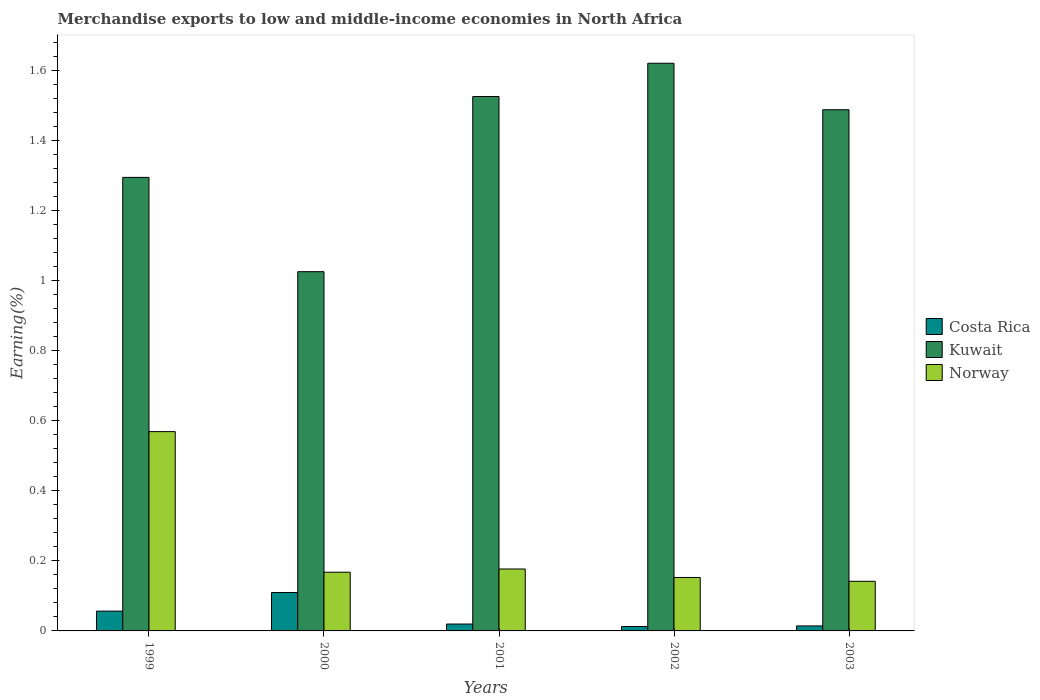How many different coloured bars are there?
Your response must be concise. 3. Are the number of bars on each tick of the X-axis equal?
Your response must be concise. Yes. How many bars are there on the 2nd tick from the right?
Your answer should be very brief. 3. What is the label of the 2nd group of bars from the left?
Keep it short and to the point. 2000. What is the percentage of amount earned from merchandise exports in Costa Rica in 1999?
Your answer should be very brief. 0.06. Across all years, what is the maximum percentage of amount earned from merchandise exports in Kuwait?
Your answer should be very brief. 1.62. Across all years, what is the minimum percentage of amount earned from merchandise exports in Norway?
Make the answer very short. 0.14. In which year was the percentage of amount earned from merchandise exports in Norway maximum?
Provide a succinct answer. 1999. What is the total percentage of amount earned from merchandise exports in Kuwait in the graph?
Keep it short and to the point. 6.95. What is the difference between the percentage of amount earned from merchandise exports in Costa Rica in 1999 and that in 2002?
Your answer should be very brief. 0.04. What is the difference between the percentage of amount earned from merchandise exports in Kuwait in 2003 and the percentage of amount earned from merchandise exports in Costa Rica in 1999?
Give a very brief answer. 1.43. What is the average percentage of amount earned from merchandise exports in Costa Rica per year?
Make the answer very short. 0.04. In the year 2000, what is the difference between the percentage of amount earned from merchandise exports in Norway and percentage of amount earned from merchandise exports in Kuwait?
Make the answer very short. -0.86. What is the ratio of the percentage of amount earned from merchandise exports in Norway in 1999 to that in 2003?
Make the answer very short. 4.02. What is the difference between the highest and the second highest percentage of amount earned from merchandise exports in Norway?
Provide a succinct answer. 0.39. What is the difference between the highest and the lowest percentage of amount earned from merchandise exports in Norway?
Offer a very short reply. 0.43. In how many years, is the percentage of amount earned from merchandise exports in Norway greater than the average percentage of amount earned from merchandise exports in Norway taken over all years?
Keep it short and to the point. 1. Is the sum of the percentage of amount earned from merchandise exports in Costa Rica in 2000 and 2001 greater than the maximum percentage of amount earned from merchandise exports in Norway across all years?
Offer a terse response. No. What does the 2nd bar from the left in 2002 represents?
Ensure brevity in your answer.  Kuwait. What does the 2nd bar from the right in 2002 represents?
Make the answer very short. Kuwait. Is it the case that in every year, the sum of the percentage of amount earned from merchandise exports in Kuwait and percentage of amount earned from merchandise exports in Costa Rica is greater than the percentage of amount earned from merchandise exports in Norway?
Give a very brief answer. Yes. Does the graph contain grids?
Ensure brevity in your answer.  No. How many legend labels are there?
Give a very brief answer. 3. How are the legend labels stacked?
Provide a succinct answer. Vertical. What is the title of the graph?
Your answer should be very brief. Merchandise exports to low and middle-income economies in North Africa. Does "Uruguay" appear as one of the legend labels in the graph?
Give a very brief answer. No. What is the label or title of the Y-axis?
Your answer should be very brief. Earning(%). What is the Earning(%) of Costa Rica in 1999?
Make the answer very short. 0.06. What is the Earning(%) of Kuwait in 1999?
Your answer should be very brief. 1.29. What is the Earning(%) of Norway in 1999?
Your answer should be very brief. 0.57. What is the Earning(%) of Costa Rica in 2000?
Your answer should be very brief. 0.11. What is the Earning(%) in Kuwait in 2000?
Provide a succinct answer. 1.03. What is the Earning(%) in Norway in 2000?
Provide a short and direct response. 0.17. What is the Earning(%) in Costa Rica in 2001?
Make the answer very short. 0.02. What is the Earning(%) of Kuwait in 2001?
Your response must be concise. 1.52. What is the Earning(%) in Norway in 2001?
Ensure brevity in your answer.  0.18. What is the Earning(%) in Costa Rica in 2002?
Your answer should be compact. 0.01. What is the Earning(%) in Kuwait in 2002?
Provide a short and direct response. 1.62. What is the Earning(%) in Norway in 2002?
Offer a terse response. 0.15. What is the Earning(%) of Costa Rica in 2003?
Ensure brevity in your answer.  0.01. What is the Earning(%) in Kuwait in 2003?
Ensure brevity in your answer.  1.49. What is the Earning(%) of Norway in 2003?
Your answer should be compact. 0.14. Across all years, what is the maximum Earning(%) in Costa Rica?
Ensure brevity in your answer.  0.11. Across all years, what is the maximum Earning(%) of Kuwait?
Provide a short and direct response. 1.62. Across all years, what is the maximum Earning(%) of Norway?
Provide a short and direct response. 0.57. Across all years, what is the minimum Earning(%) in Costa Rica?
Offer a very short reply. 0.01. Across all years, what is the minimum Earning(%) in Kuwait?
Your answer should be very brief. 1.03. Across all years, what is the minimum Earning(%) in Norway?
Provide a succinct answer. 0.14. What is the total Earning(%) in Costa Rica in the graph?
Your answer should be very brief. 0.21. What is the total Earning(%) in Kuwait in the graph?
Provide a short and direct response. 6.95. What is the total Earning(%) in Norway in the graph?
Keep it short and to the point. 1.21. What is the difference between the Earning(%) of Costa Rica in 1999 and that in 2000?
Offer a terse response. -0.05. What is the difference between the Earning(%) in Kuwait in 1999 and that in 2000?
Offer a terse response. 0.27. What is the difference between the Earning(%) in Norway in 1999 and that in 2000?
Keep it short and to the point. 0.4. What is the difference between the Earning(%) of Costa Rica in 1999 and that in 2001?
Offer a terse response. 0.04. What is the difference between the Earning(%) of Kuwait in 1999 and that in 2001?
Ensure brevity in your answer.  -0.23. What is the difference between the Earning(%) of Norway in 1999 and that in 2001?
Offer a very short reply. 0.39. What is the difference between the Earning(%) of Costa Rica in 1999 and that in 2002?
Keep it short and to the point. 0.04. What is the difference between the Earning(%) in Kuwait in 1999 and that in 2002?
Provide a short and direct response. -0.33. What is the difference between the Earning(%) in Norway in 1999 and that in 2002?
Your response must be concise. 0.42. What is the difference between the Earning(%) of Costa Rica in 1999 and that in 2003?
Keep it short and to the point. 0.04. What is the difference between the Earning(%) of Kuwait in 1999 and that in 2003?
Provide a succinct answer. -0.19. What is the difference between the Earning(%) of Norway in 1999 and that in 2003?
Give a very brief answer. 0.43. What is the difference between the Earning(%) of Costa Rica in 2000 and that in 2001?
Your answer should be very brief. 0.09. What is the difference between the Earning(%) of Kuwait in 2000 and that in 2001?
Make the answer very short. -0.5. What is the difference between the Earning(%) of Norway in 2000 and that in 2001?
Your response must be concise. -0.01. What is the difference between the Earning(%) of Costa Rica in 2000 and that in 2002?
Offer a very short reply. 0.1. What is the difference between the Earning(%) in Kuwait in 2000 and that in 2002?
Offer a very short reply. -0.59. What is the difference between the Earning(%) in Norway in 2000 and that in 2002?
Keep it short and to the point. 0.01. What is the difference between the Earning(%) of Costa Rica in 2000 and that in 2003?
Ensure brevity in your answer.  0.1. What is the difference between the Earning(%) in Kuwait in 2000 and that in 2003?
Your response must be concise. -0.46. What is the difference between the Earning(%) in Norway in 2000 and that in 2003?
Keep it short and to the point. 0.03. What is the difference between the Earning(%) in Costa Rica in 2001 and that in 2002?
Your answer should be very brief. 0.01. What is the difference between the Earning(%) of Kuwait in 2001 and that in 2002?
Your answer should be compact. -0.09. What is the difference between the Earning(%) in Norway in 2001 and that in 2002?
Offer a very short reply. 0.02. What is the difference between the Earning(%) of Costa Rica in 2001 and that in 2003?
Make the answer very short. 0.01. What is the difference between the Earning(%) in Kuwait in 2001 and that in 2003?
Your answer should be compact. 0.04. What is the difference between the Earning(%) in Norway in 2001 and that in 2003?
Offer a terse response. 0.04. What is the difference between the Earning(%) of Costa Rica in 2002 and that in 2003?
Make the answer very short. -0. What is the difference between the Earning(%) in Kuwait in 2002 and that in 2003?
Offer a very short reply. 0.13. What is the difference between the Earning(%) of Norway in 2002 and that in 2003?
Your response must be concise. 0.01. What is the difference between the Earning(%) in Costa Rica in 1999 and the Earning(%) in Kuwait in 2000?
Offer a very short reply. -0.97. What is the difference between the Earning(%) of Costa Rica in 1999 and the Earning(%) of Norway in 2000?
Offer a very short reply. -0.11. What is the difference between the Earning(%) of Kuwait in 1999 and the Earning(%) of Norway in 2000?
Offer a terse response. 1.13. What is the difference between the Earning(%) of Costa Rica in 1999 and the Earning(%) of Kuwait in 2001?
Give a very brief answer. -1.47. What is the difference between the Earning(%) in Costa Rica in 1999 and the Earning(%) in Norway in 2001?
Your answer should be very brief. -0.12. What is the difference between the Earning(%) of Kuwait in 1999 and the Earning(%) of Norway in 2001?
Give a very brief answer. 1.12. What is the difference between the Earning(%) of Costa Rica in 1999 and the Earning(%) of Kuwait in 2002?
Offer a very short reply. -1.56. What is the difference between the Earning(%) in Costa Rica in 1999 and the Earning(%) in Norway in 2002?
Provide a succinct answer. -0.1. What is the difference between the Earning(%) in Kuwait in 1999 and the Earning(%) in Norway in 2002?
Provide a short and direct response. 1.14. What is the difference between the Earning(%) of Costa Rica in 1999 and the Earning(%) of Kuwait in 2003?
Offer a terse response. -1.43. What is the difference between the Earning(%) of Costa Rica in 1999 and the Earning(%) of Norway in 2003?
Provide a succinct answer. -0.09. What is the difference between the Earning(%) in Kuwait in 1999 and the Earning(%) in Norway in 2003?
Offer a terse response. 1.15. What is the difference between the Earning(%) of Costa Rica in 2000 and the Earning(%) of Kuwait in 2001?
Offer a terse response. -1.42. What is the difference between the Earning(%) of Costa Rica in 2000 and the Earning(%) of Norway in 2001?
Make the answer very short. -0.07. What is the difference between the Earning(%) in Kuwait in 2000 and the Earning(%) in Norway in 2001?
Provide a succinct answer. 0.85. What is the difference between the Earning(%) in Costa Rica in 2000 and the Earning(%) in Kuwait in 2002?
Make the answer very short. -1.51. What is the difference between the Earning(%) of Costa Rica in 2000 and the Earning(%) of Norway in 2002?
Give a very brief answer. -0.04. What is the difference between the Earning(%) of Kuwait in 2000 and the Earning(%) of Norway in 2002?
Ensure brevity in your answer.  0.87. What is the difference between the Earning(%) in Costa Rica in 2000 and the Earning(%) in Kuwait in 2003?
Give a very brief answer. -1.38. What is the difference between the Earning(%) of Costa Rica in 2000 and the Earning(%) of Norway in 2003?
Ensure brevity in your answer.  -0.03. What is the difference between the Earning(%) in Kuwait in 2000 and the Earning(%) in Norway in 2003?
Your answer should be very brief. 0.88. What is the difference between the Earning(%) of Costa Rica in 2001 and the Earning(%) of Kuwait in 2002?
Your response must be concise. -1.6. What is the difference between the Earning(%) of Costa Rica in 2001 and the Earning(%) of Norway in 2002?
Ensure brevity in your answer.  -0.13. What is the difference between the Earning(%) of Kuwait in 2001 and the Earning(%) of Norway in 2002?
Ensure brevity in your answer.  1.37. What is the difference between the Earning(%) in Costa Rica in 2001 and the Earning(%) in Kuwait in 2003?
Your response must be concise. -1.47. What is the difference between the Earning(%) in Costa Rica in 2001 and the Earning(%) in Norway in 2003?
Your response must be concise. -0.12. What is the difference between the Earning(%) of Kuwait in 2001 and the Earning(%) of Norway in 2003?
Ensure brevity in your answer.  1.38. What is the difference between the Earning(%) in Costa Rica in 2002 and the Earning(%) in Kuwait in 2003?
Provide a short and direct response. -1.47. What is the difference between the Earning(%) in Costa Rica in 2002 and the Earning(%) in Norway in 2003?
Make the answer very short. -0.13. What is the difference between the Earning(%) of Kuwait in 2002 and the Earning(%) of Norway in 2003?
Give a very brief answer. 1.48. What is the average Earning(%) of Costa Rica per year?
Ensure brevity in your answer.  0.04. What is the average Earning(%) in Kuwait per year?
Make the answer very short. 1.39. What is the average Earning(%) of Norway per year?
Ensure brevity in your answer.  0.24. In the year 1999, what is the difference between the Earning(%) of Costa Rica and Earning(%) of Kuwait?
Provide a short and direct response. -1.24. In the year 1999, what is the difference between the Earning(%) of Costa Rica and Earning(%) of Norway?
Provide a short and direct response. -0.51. In the year 1999, what is the difference between the Earning(%) in Kuwait and Earning(%) in Norway?
Provide a succinct answer. 0.73. In the year 2000, what is the difference between the Earning(%) in Costa Rica and Earning(%) in Kuwait?
Your answer should be compact. -0.92. In the year 2000, what is the difference between the Earning(%) in Costa Rica and Earning(%) in Norway?
Your answer should be very brief. -0.06. In the year 2000, what is the difference between the Earning(%) in Kuwait and Earning(%) in Norway?
Your answer should be compact. 0.86. In the year 2001, what is the difference between the Earning(%) of Costa Rica and Earning(%) of Kuwait?
Ensure brevity in your answer.  -1.51. In the year 2001, what is the difference between the Earning(%) in Costa Rica and Earning(%) in Norway?
Offer a very short reply. -0.16. In the year 2001, what is the difference between the Earning(%) of Kuwait and Earning(%) of Norway?
Your response must be concise. 1.35. In the year 2002, what is the difference between the Earning(%) of Costa Rica and Earning(%) of Kuwait?
Make the answer very short. -1.61. In the year 2002, what is the difference between the Earning(%) of Costa Rica and Earning(%) of Norway?
Provide a succinct answer. -0.14. In the year 2002, what is the difference between the Earning(%) of Kuwait and Earning(%) of Norway?
Ensure brevity in your answer.  1.47. In the year 2003, what is the difference between the Earning(%) of Costa Rica and Earning(%) of Kuwait?
Keep it short and to the point. -1.47. In the year 2003, what is the difference between the Earning(%) of Costa Rica and Earning(%) of Norway?
Provide a succinct answer. -0.13. In the year 2003, what is the difference between the Earning(%) of Kuwait and Earning(%) of Norway?
Give a very brief answer. 1.35. What is the ratio of the Earning(%) in Costa Rica in 1999 to that in 2000?
Provide a short and direct response. 0.52. What is the ratio of the Earning(%) in Kuwait in 1999 to that in 2000?
Your answer should be compact. 1.26. What is the ratio of the Earning(%) in Norway in 1999 to that in 2000?
Give a very brief answer. 3.39. What is the ratio of the Earning(%) of Costa Rica in 1999 to that in 2001?
Ensure brevity in your answer.  2.88. What is the ratio of the Earning(%) of Kuwait in 1999 to that in 2001?
Provide a short and direct response. 0.85. What is the ratio of the Earning(%) of Norway in 1999 to that in 2001?
Your response must be concise. 3.22. What is the ratio of the Earning(%) of Costa Rica in 1999 to that in 2002?
Your answer should be compact. 4.51. What is the ratio of the Earning(%) in Kuwait in 1999 to that in 2002?
Give a very brief answer. 0.8. What is the ratio of the Earning(%) of Norway in 1999 to that in 2002?
Give a very brief answer. 3.73. What is the ratio of the Earning(%) in Costa Rica in 1999 to that in 2003?
Offer a very short reply. 3.97. What is the ratio of the Earning(%) in Kuwait in 1999 to that in 2003?
Your answer should be compact. 0.87. What is the ratio of the Earning(%) of Norway in 1999 to that in 2003?
Keep it short and to the point. 4.02. What is the ratio of the Earning(%) of Costa Rica in 2000 to that in 2001?
Offer a terse response. 5.58. What is the ratio of the Earning(%) of Kuwait in 2000 to that in 2001?
Your answer should be very brief. 0.67. What is the ratio of the Earning(%) in Norway in 2000 to that in 2001?
Provide a short and direct response. 0.95. What is the ratio of the Earning(%) in Costa Rica in 2000 to that in 2002?
Offer a very short reply. 8.74. What is the ratio of the Earning(%) of Kuwait in 2000 to that in 2002?
Your answer should be compact. 0.63. What is the ratio of the Earning(%) of Norway in 2000 to that in 2002?
Give a very brief answer. 1.1. What is the ratio of the Earning(%) of Costa Rica in 2000 to that in 2003?
Your answer should be very brief. 7.7. What is the ratio of the Earning(%) of Kuwait in 2000 to that in 2003?
Your response must be concise. 0.69. What is the ratio of the Earning(%) of Norway in 2000 to that in 2003?
Make the answer very short. 1.18. What is the ratio of the Earning(%) in Costa Rica in 2001 to that in 2002?
Offer a very short reply. 1.57. What is the ratio of the Earning(%) in Kuwait in 2001 to that in 2002?
Provide a short and direct response. 0.94. What is the ratio of the Earning(%) of Norway in 2001 to that in 2002?
Provide a short and direct response. 1.16. What is the ratio of the Earning(%) in Costa Rica in 2001 to that in 2003?
Keep it short and to the point. 1.38. What is the ratio of the Earning(%) of Kuwait in 2001 to that in 2003?
Keep it short and to the point. 1.03. What is the ratio of the Earning(%) of Norway in 2001 to that in 2003?
Your response must be concise. 1.25. What is the ratio of the Earning(%) in Costa Rica in 2002 to that in 2003?
Provide a short and direct response. 0.88. What is the ratio of the Earning(%) of Kuwait in 2002 to that in 2003?
Provide a succinct answer. 1.09. What is the ratio of the Earning(%) in Norway in 2002 to that in 2003?
Ensure brevity in your answer.  1.08. What is the difference between the highest and the second highest Earning(%) of Costa Rica?
Provide a short and direct response. 0.05. What is the difference between the highest and the second highest Earning(%) of Kuwait?
Make the answer very short. 0.09. What is the difference between the highest and the second highest Earning(%) of Norway?
Your answer should be very brief. 0.39. What is the difference between the highest and the lowest Earning(%) in Costa Rica?
Ensure brevity in your answer.  0.1. What is the difference between the highest and the lowest Earning(%) in Kuwait?
Ensure brevity in your answer.  0.59. What is the difference between the highest and the lowest Earning(%) in Norway?
Your response must be concise. 0.43. 